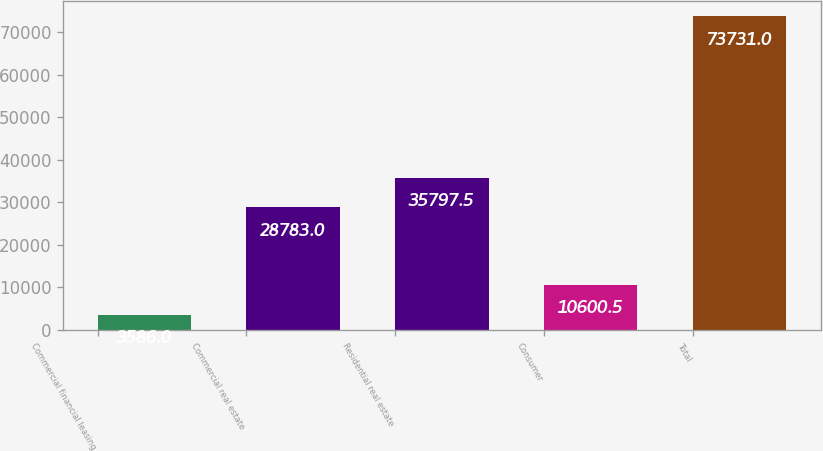<chart> <loc_0><loc_0><loc_500><loc_500><bar_chart><fcel>Commercial financial leasing<fcel>Commercial real estate<fcel>Residential real estate<fcel>Consumer<fcel>Total<nl><fcel>3586<fcel>28783<fcel>35797.5<fcel>10600.5<fcel>73731<nl></chart> 